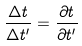Convert formula to latex. <formula><loc_0><loc_0><loc_500><loc_500>\frac { \Delta t } { \Delta t ^ { \prime } } = \frac { \partial t } { \partial t ^ { \prime } }</formula> 